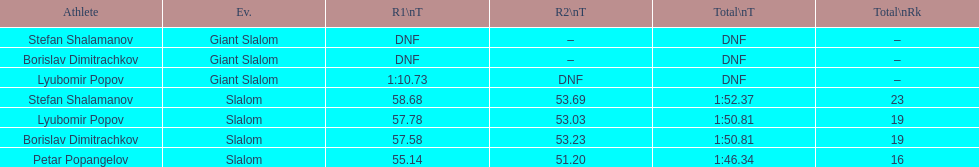What is the difference in time for petar popangelov in race 1and 2 3.94. 